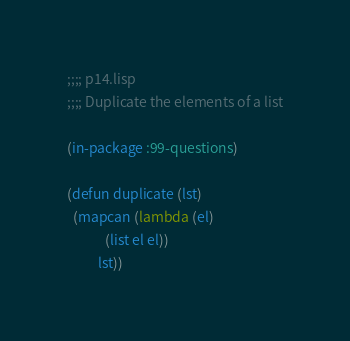Convert code to text. <code><loc_0><loc_0><loc_500><loc_500><_Lisp_>;;;; p14.lisp
;;;; Duplicate the elements of a list

(in-package :99-questions)

(defun duplicate (lst)
  (mapcan (lambda (el)
            (list el el))
          lst))
</code> 